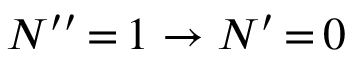Convert formula to latex. <formula><loc_0><loc_0><loc_500><loc_500>N ^ { \prime \prime } \, { = } \, 1 \rightarrow N ^ { \prime } \, { = } \, 0</formula> 